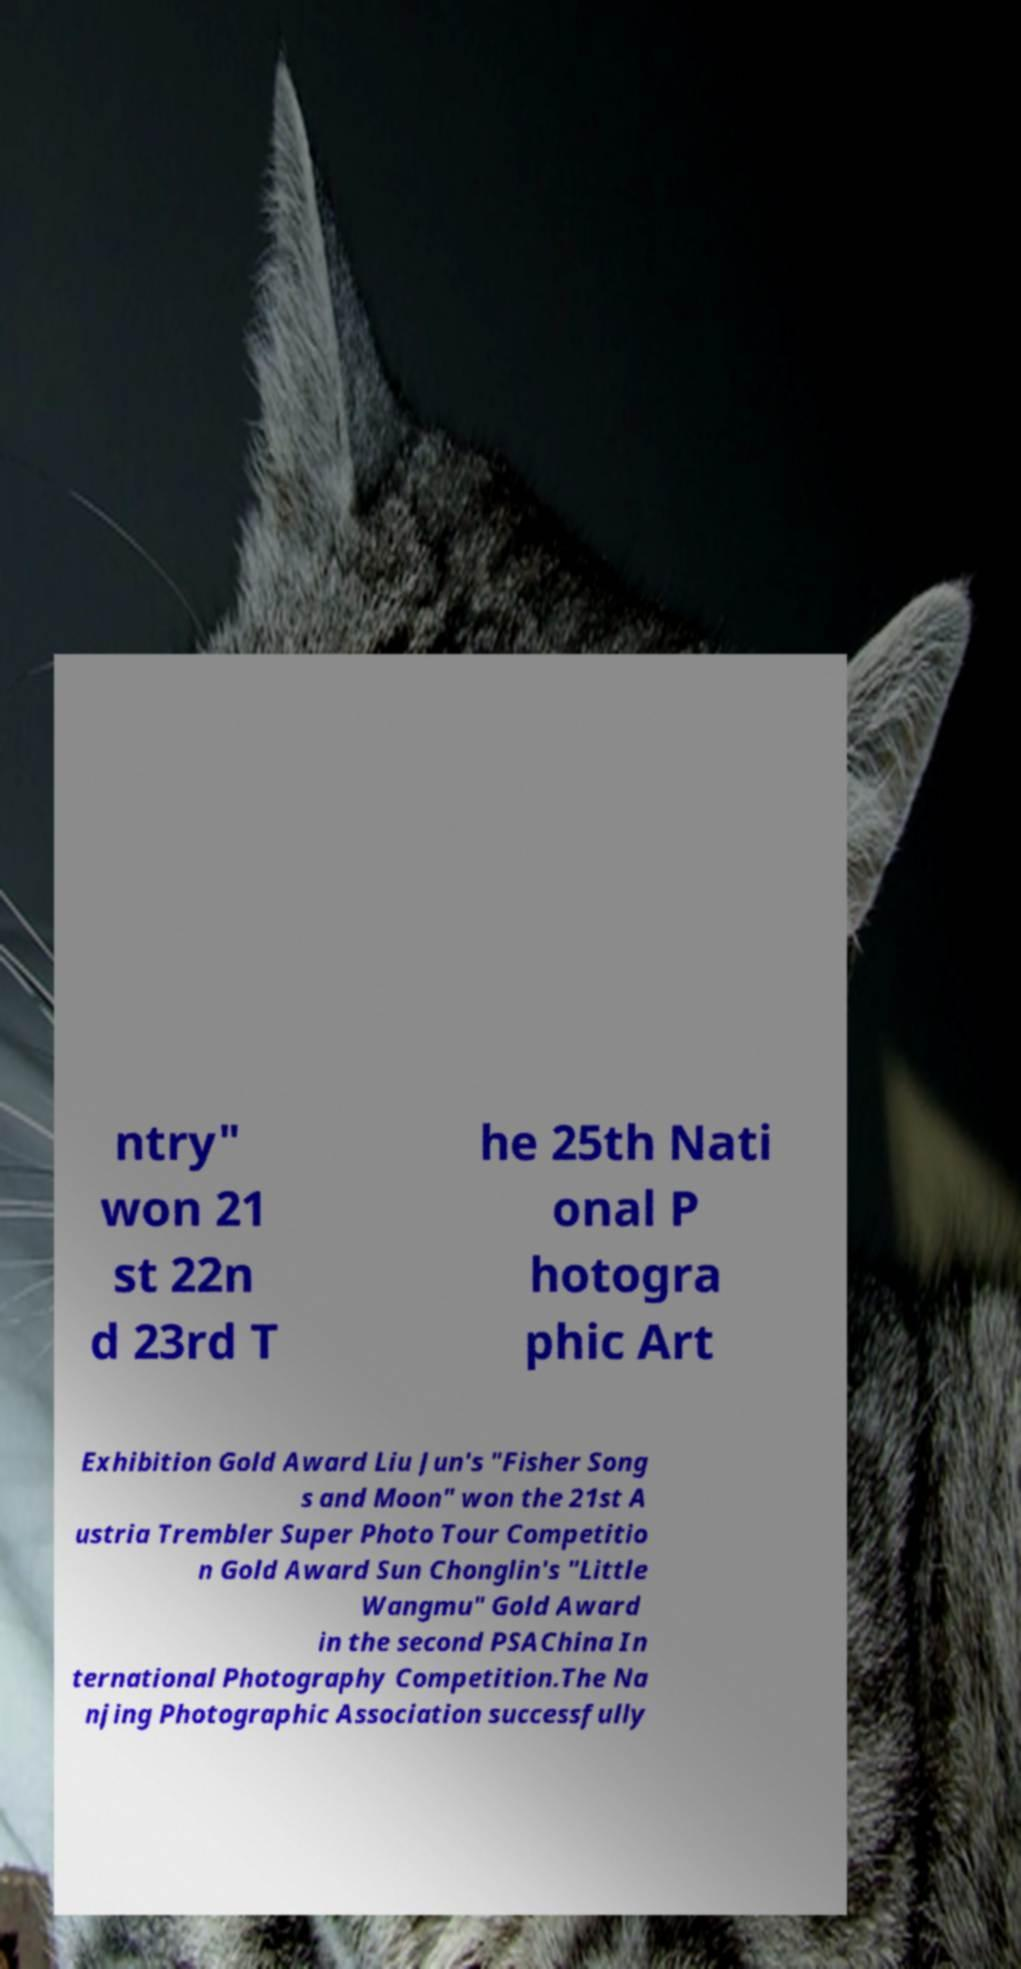There's text embedded in this image that I need extracted. Can you transcribe it verbatim? ntry" won 21 st 22n d 23rd T he 25th Nati onal P hotogra phic Art Exhibition Gold Award Liu Jun's "Fisher Song s and Moon" won the 21st A ustria Trembler Super Photo Tour Competitio n Gold Award Sun Chonglin's "Little Wangmu" Gold Award in the second PSAChina In ternational Photography Competition.The Na njing Photographic Association successfully 